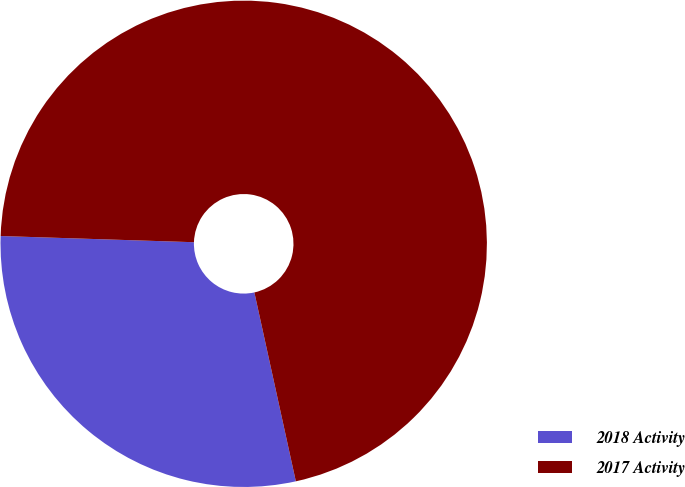Convert chart. <chart><loc_0><loc_0><loc_500><loc_500><pie_chart><fcel>2018 Activity<fcel>2017 Activity<nl><fcel>28.95%<fcel>71.05%<nl></chart> 